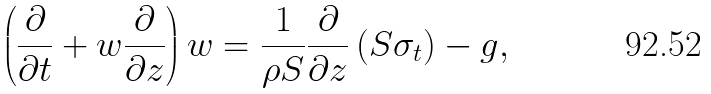<formula> <loc_0><loc_0><loc_500><loc_500>\left ( \frac { \partial } { \partial t } + w \frac { \partial } { \partial z } \right ) w = \frac { 1 } { \rho S } \frac { \partial } { \partial z } \left ( S \sigma _ { t } \right ) - g ,</formula> 